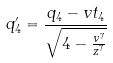<formula> <loc_0><loc_0><loc_500><loc_500>q _ { 4 } ^ { \prime } = \frac { q _ { 4 } - v t _ { 4 } } { \sqrt { 4 - \frac { v ^ { 7 } } { z ^ { 7 } } } }</formula> 